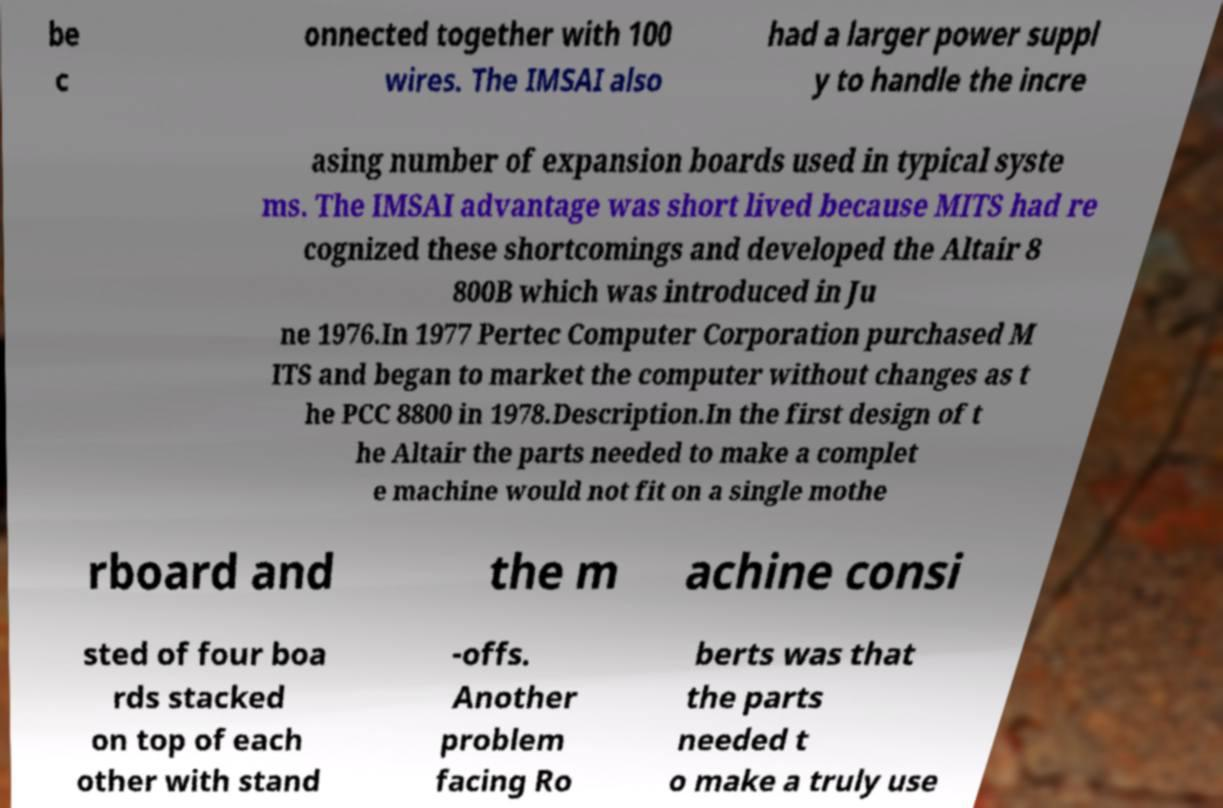I need the written content from this picture converted into text. Can you do that? be c onnected together with 100 wires. The IMSAI also had a larger power suppl y to handle the incre asing number of expansion boards used in typical syste ms. The IMSAI advantage was short lived because MITS had re cognized these shortcomings and developed the Altair 8 800B which was introduced in Ju ne 1976.In 1977 Pertec Computer Corporation purchased M ITS and began to market the computer without changes as t he PCC 8800 in 1978.Description.In the first design of t he Altair the parts needed to make a complet e machine would not fit on a single mothe rboard and the m achine consi sted of four boa rds stacked on top of each other with stand -offs. Another problem facing Ro berts was that the parts needed t o make a truly use 